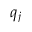<formula> <loc_0><loc_0><loc_500><loc_500>q _ { j }</formula> 